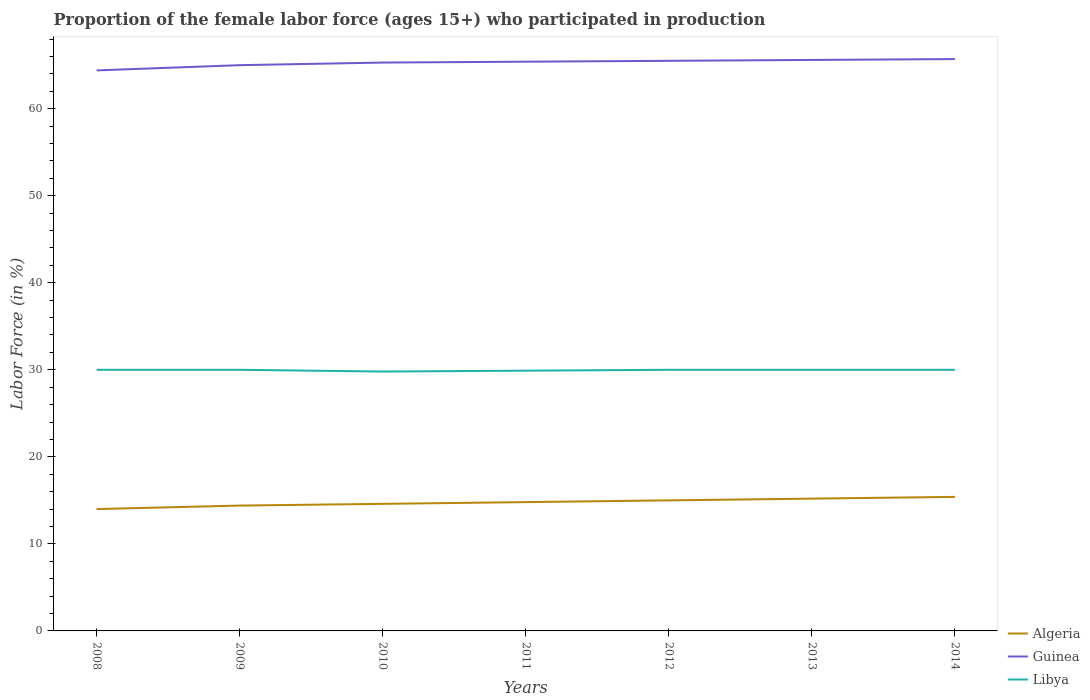Across all years, what is the maximum proportion of the female labor force who participated in production in Guinea?
Your answer should be very brief. 64.4. What is the total proportion of the female labor force who participated in production in Libya in the graph?
Your response must be concise. 0.1. What is the difference between the highest and the second highest proportion of the female labor force who participated in production in Guinea?
Keep it short and to the point. 1.3. What is the difference between the highest and the lowest proportion of the female labor force who participated in production in Algeria?
Provide a short and direct response. 4. How many years are there in the graph?
Your response must be concise. 7. What is the difference between two consecutive major ticks on the Y-axis?
Keep it short and to the point. 10. How many legend labels are there?
Provide a short and direct response. 3. What is the title of the graph?
Offer a terse response. Proportion of the female labor force (ages 15+) who participated in production. Does "Middle East & North Africa (developing only)" appear as one of the legend labels in the graph?
Offer a terse response. No. What is the label or title of the X-axis?
Offer a terse response. Years. What is the label or title of the Y-axis?
Your response must be concise. Labor Force (in %). What is the Labor Force (in %) in Guinea in 2008?
Your answer should be compact. 64.4. What is the Labor Force (in %) in Libya in 2008?
Keep it short and to the point. 30. What is the Labor Force (in %) of Algeria in 2009?
Offer a very short reply. 14.4. What is the Labor Force (in %) in Libya in 2009?
Ensure brevity in your answer.  30. What is the Labor Force (in %) in Algeria in 2010?
Provide a succinct answer. 14.6. What is the Labor Force (in %) of Guinea in 2010?
Provide a succinct answer. 65.3. What is the Labor Force (in %) of Libya in 2010?
Provide a succinct answer. 29.8. What is the Labor Force (in %) in Algeria in 2011?
Your response must be concise. 14.8. What is the Labor Force (in %) of Guinea in 2011?
Your response must be concise. 65.4. What is the Labor Force (in %) of Libya in 2011?
Keep it short and to the point. 29.9. What is the Labor Force (in %) in Algeria in 2012?
Your answer should be compact. 15. What is the Labor Force (in %) in Guinea in 2012?
Offer a very short reply. 65.5. What is the Labor Force (in %) in Libya in 2012?
Your answer should be compact. 30. What is the Labor Force (in %) of Algeria in 2013?
Your response must be concise. 15.2. What is the Labor Force (in %) in Guinea in 2013?
Ensure brevity in your answer.  65.6. What is the Labor Force (in %) in Algeria in 2014?
Keep it short and to the point. 15.4. What is the Labor Force (in %) in Guinea in 2014?
Your answer should be compact. 65.7. Across all years, what is the maximum Labor Force (in %) of Algeria?
Your answer should be compact. 15.4. Across all years, what is the maximum Labor Force (in %) of Guinea?
Offer a terse response. 65.7. Across all years, what is the maximum Labor Force (in %) of Libya?
Make the answer very short. 30. Across all years, what is the minimum Labor Force (in %) of Algeria?
Your response must be concise. 14. Across all years, what is the minimum Labor Force (in %) of Guinea?
Keep it short and to the point. 64.4. Across all years, what is the minimum Labor Force (in %) of Libya?
Provide a succinct answer. 29.8. What is the total Labor Force (in %) in Algeria in the graph?
Ensure brevity in your answer.  103.4. What is the total Labor Force (in %) of Guinea in the graph?
Offer a very short reply. 456.9. What is the total Labor Force (in %) of Libya in the graph?
Make the answer very short. 209.7. What is the difference between the Labor Force (in %) of Algeria in 2008 and that in 2009?
Your response must be concise. -0.4. What is the difference between the Labor Force (in %) of Guinea in 2008 and that in 2009?
Your response must be concise. -0.6. What is the difference between the Labor Force (in %) of Libya in 2008 and that in 2009?
Your answer should be very brief. 0. What is the difference between the Labor Force (in %) in Guinea in 2008 and that in 2010?
Offer a terse response. -0.9. What is the difference between the Labor Force (in %) in Libya in 2008 and that in 2010?
Your response must be concise. 0.2. What is the difference between the Labor Force (in %) of Algeria in 2008 and that in 2011?
Ensure brevity in your answer.  -0.8. What is the difference between the Labor Force (in %) in Guinea in 2008 and that in 2011?
Offer a terse response. -1. What is the difference between the Labor Force (in %) of Algeria in 2008 and that in 2012?
Keep it short and to the point. -1. What is the difference between the Labor Force (in %) of Guinea in 2008 and that in 2013?
Offer a terse response. -1.2. What is the difference between the Labor Force (in %) in Libya in 2008 and that in 2013?
Ensure brevity in your answer.  0. What is the difference between the Labor Force (in %) in Libya in 2008 and that in 2014?
Provide a succinct answer. 0. What is the difference between the Labor Force (in %) in Libya in 2009 and that in 2011?
Offer a terse response. 0.1. What is the difference between the Labor Force (in %) in Libya in 2009 and that in 2012?
Keep it short and to the point. 0. What is the difference between the Labor Force (in %) in Algeria in 2009 and that in 2014?
Your answer should be compact. -1. What is the difference between the Labor Force (in %) of Guinea in 2009 and that in 2014?
Make the answer very short. -0.7. What is the difference between the Labor Force (in %) in Algeria in 2010 and that in 2011?
Make the answer very short. -0.2. What is the difference between the Labor Force (in %) of Guinea in 2010 and that in 2011?
Ensure brevity in your answer.  -0.1. What is the difference between the Labor Force (in %) in Libya in 2010 and that in 2011?
Make the answer very short. -0.1. What is the difference between the Labor Force (in %) in Algeria in 2010 and that in 2012?
Ensure brevity in your answer.  -0.4. What is the difference between the Labor Force (in %) of Algeria in 2010 and that in 2013?
Make the answer very short. -0.6. What is the difference between the Labor Force (in %) of Guinea in 2010 and that in 2013?
Your response must be concise. -0.3. What is the difference between the Labor Force (in %) in Libya in 2010 and that in 2013?
Keep it short and to the point. -0.2. What is the difference between the Labor Force (in %) of Guinea in 2010 and that in 2014?
Ensure brevity in your answer.  -0.4. What is the difference between the Labor Force (in %) of Libya in 2010 and that in 2014?
Provide a succinct answer. -0.2. What is the difference between the Labor Force (in %) of Algeria in 2011 and that in 2014?
Offer a very short reply. -0.6. What is the difference between the Labor Force (in %) in Guinea in 2011 and that in 2014?
Provide a short and direct response. -0.3. What is the difference between the Labor Force (in %) of Libya in 2011 and that in 2014?
Your answer should be compact. -0.1. What is the difference between the Labor Force (in %) in Guinea in 2012 and that in 2013?
Provide a succinct answer. -0.1. What is the difference between the Labor Force (in %) in Libya in 2012 and that in 2013?
Offer a very short reply. 0. What is the difference between the Labor Force (in %) of Guinea in 2012 and that in 2014?
Your response must be concise. -0.2. What is the difference between the Labor Force (in %) in Libya in 2012 and that in 2014?
Keep it short and to the point. 0. What is the difference between the Labor Force (in %) of Algeria in 2008 and the Labor Force (in %) of Guinea in 2009?
Keep it short and to the point. -51. What is the difference between the Labor Force (in %) of Guinea in 2008 and the Labor Force (in %) of Libya in 2009?
Offer a very short reply. 34.4. What is the difference between the Labor Force (in %) in Algeria in 2008 and the Labor Force (in %) in Guinea in 2010?
Give a very brief answer. -51.3. What is the difference between the Labor Force (in %) in Algeria in 2008 and the Labor Force (in %) in Libya in 2010?
Offer a terse response. -15.8. What is the difference between the Labor Force (in %) in Guinea in 2008 and the Labor Force (in %) in Libya in 2010?
Your response must be concise. 34.6. What is the difference between the Labor Force (in %) in Algeria in 2008 and the Labor Force (in %) in Guinea in 2011?
Your answer should be very brief. -51.4. What is the difference between the Labor Force (in %) of Algeria in 2008 and the Labor Force (in %) of Libya in 2011?
Your answer should be very brief. -15.9. What is the difference between the Labor Force (in %) in Guinea in 2008 and the Labor Force (in %) in Libya in 2011?
Provide a short and direct response. 34.5. What is the difference between the Labor Force (in %) in Algeria in 2008 and the Labor Force (in %) in Guinea in 2012?
Your answer should be compact. -51.5. What is the difference between the Labor Force (in %) in Guinea in 2008 and the Labor Force (in %) in Libya in 2012?
Your answer should be compact. 34.4. What is the difference between the Labor Force (in %) of Algeria in 2008 and the Labor Force (in %) of Guinea in 2013?
Give a very brief answer. -51.6. What is the difference between the Labor Force (in %) in Algeria in 2008 and the Labor Force (in %) in Libya in 2013?
Keep it short and to the point. -16. What is the difference between the Labor Force (in %) in Guinea in 2008 and the Labor Force (in %) in Libya in 2013?
Keep it short and to the point. 34.4. What is the difference between the Labor Force (in %) in Algeria in 2008 and the Labor Force (in %) in Guinea in 2014?
Offer a very short reply. -51.7. What is the difference between the Labor Force (in %) in Algeria in 2008 and the Labor Force (in %) in Libya in 2014?
Offer a very short reply. -16. What is the difference between the Labor Force (in %) of Guinea in 2008 and the Labor Force (in %) of Libya in 2014?
Your response must be concise. 34.4. What is the difference between the Labor Force (in %) of Algeria in 2009 and the Labor Force (in %) of Guinea in 2010?
Give a very brief answer. -50.9. What is the difference between the Labor Force (in %) of Algeria in 2009 and the Labor Force (in %) of Libya in 2010?
Your answer should be very brief. -15.4. What is the difference between the Labor Force (in %) of Guinea in 2009 and the Labor Force (in %) of Libya in 2010?
Your answer should be compact. 35.2. What is the difference between the Labor Force (in %) of Algeria in 2009 and the Labor Force (in %) of Guinea in 2011?
Offer a very short reply. -51. What is the difference between the Labor Force (in %) in Algeria in 2009 and the Labor Force (in %) in Libya in 2011?
Offer a very short reply. -15.5. What is the difference between the Labor Force (in %) in Guinea in 2009 and the Labor Force (in %) in Libya in 2011?
Your answer should be compact. 35.1. What is the difference between the Labor Force (in %) in Algeria in 2009 and the Labor Force (in %) in Guinea in 2012?
Make the answer very short. -51.1. What is the difference between the Labor Force (in %) in Algeria in 2009 and the Labor Force (in %) in Libya in 2012?
Give a very brief answer. -15.6. What is the difference between the Labor Force (in %) in Algeria in 2009 and the Labor Force (in %) in Guinea in 2013?
Provide a short and direct response. -51.2. What is the difference between the Labor Force (in %) in Algeria in 2009 and the Labor Force (in %) in Libya in 2013?
Provide a succinct answer. -15.6. What is the difference between the Labor Force (in %) in Guinea in 2009 and the Labor Force (in %) in Libya in 2013?
Ensure brevity in your answer.  35. What is the difference between the Labor Force (in %) of Algeria in 2009 and the Labor Force (in %) of Guinea in 2014?
Make the answer very short. -51.3. What is the difference between the Labor Force (in %) of Algeria in 2009 and the Labor Force (in %) of Libya in 2014?
Your response must be concise. -15.6. What is the difference between the Labor Force (in %) of Guinea in 2009 and the Labor Force (in %) of Libya in 2014?
Offer a terse response. 35. What is the difference between the Labor Force (in %) of Algeria in 2010 and the Labor Force (in %) of Guinea in 2011?
Provide a succinct answer. -50.8. What is the difference between the Labor Force (in %) in Algeria in 2010 and the Labor Force (in %) in Libya in 2011?
Your response must be concise. -15.3. What is the difference between the Labor Force (in %) of Guinea in 2010 and the Labor Force (in %) of Libya in 2011?
Your response must be concise. 35.4. What is the difference between the Labor Force (in %) in Algeria in 2010 and the Labor Force (in %) in Guinea in 2012?
Ensure brevity in your answer.  -50.9. What is the difference between the Labor Force (in %) of Algeria in 2010 and the Labor Force (in %) of Libya in 2012?
Offer a very short reply. -15.4. What is the difference between the Labor Force (in %) in Guinea in 2010 and the Labor Force (in %) in Libya in 2012?
Give a very brief answer. 35.3. What is the difference between the Labor Force (in %) in Algeria in 2010 and the Labor Force (in %) in Guinea in 2013?
Provide a short and direct response. -51. What is the difference between the Labor Force (in %) of Algeria in 2010 and the Labor Force (in %) of Libya in 2013?
Provide a succinct answer. -15.4. What is the difference between the Labor Force (in %) in Guinea in 2010 and the Labor Force (in %) in Libya in 2013?
Provide a short and direct response. 35.3. What is the difference between the Labor Force (in %) of Algeria in 2010 and the Labor Force (in %) of Guinea in 2014?
Offer a terse response. -51.1. What is the difference between the Labor Force (in %) of Algeria in 2010 and the Labor Force (in %) of Libya in 2014?
Your answer should be compact. -15.4. What is the difference between the Labor Force (in %) in Guinea in 2010 and the Labor Force (in %) in Libya in 2014?
Give a very brief answer. 35.3. What is the difference between the Labor Force (in %) of Algeria in 2011 and the Labor Force (in %) of Guinea in 2012?
Provide a succinct answer. -50.7. What is the difference between the Labor Force (in %) in Algeria in 2011 and the Labor Force (in %) in Libya in 2012?
Offer a terse response. -15.2. What is the difference between the Labor Force (in %) in Guinea in 2011 and the Labor Force (in %) in Libya in 2012?
Your answer should be very brief. 35.4. What is the difference between the Labor Force (in %) in Algeria in 2011 and the Labor Force (in %) in Guinea in 2013?
Offer a terse response. -50.8. What is the difference between the Labor Force (in %) of Algeria in 2011 and the Labor Force (in %) of Libya in 2013?
Your answer should be very brief. -15.2. What is the difference between the Labor Force (in %) in Guinea in 2011 and the Labor Force (in %) in Libya in 2013?
Your response must be concise. 35.4. What is the difference between the Labor Force (in %) in Algeria in 2011 and the Labor Force (in %) in Guinea in 2014?
Provide a succinct answer. -50.9. What is the difference between the Labor Force (in %) of Algeria in 2011 and the Labor Force (in %) of Libya in 2014?
Offer a terse response. -15.2. What is the difference between the Labor Force (in %) of Guinea in 2011 and the Labor Force (in %) of Libya in 2014?
Make the answer very short. 35.4. What is the difference between the Labor Force (in %) in Algeria in 2012 and the Labor Force (in %) in Guinea in 2013?
Give a very brief answer. -50.6. What is the difference between the Labor Force (in %) in Algeria in 2012 and the Labor Force (in %) in Libya in 2013?
Provide a short and direct response. -15. What is the difference between the Labor Force (in %) in Guinea in 2012 and the Labor Force (in %) in Libya in 2013?
Provide a short and direct response. 35.5. What is the difference between the Labor Force (in %) in Algeria in 2012 and the Labor Force (in %) in Guinea in 2014?
Provide a succinct answer. -50.7. What is the difference between the Labor Force (in %) in Guinea in 2012 and the Labor Force (in %) in Libya in 2014?
Provide a short and direct response. 35.5. What is the difference between the Labor Force (in %) in Algeria in 2013 and the Labor Force (in %) in Guinea in 2014?
Ensure brevity in your answer.  -50.5. What is the difference between the Labor Force (in %) of Algeria in 2013 and the Labor Force (in %) of Libya in 2014?
Your answer should be compact. -14.8. What is the difference between the Labor Force (in %) of Guinea in 2013 and the Labor Force (in %) of Libya in 2014?
Your answer should be very brief. 35.6. What is the average Labor Force (in %) in Algeria per year?
Give a very brief answer. 14.77. What is the average Labor Force (in %) of Guinea per year?
Offer a very short reply. 65.27. What is the average Labor Force (in %) of Libya per year?
Ensure brevity in your answer.  29.96. In the year 2008, what is the difference between the Labor Force (in %) in Algeria and Labor Force (in %) in Guinea?
Provide a short and direct response. -50.4. In the year 2008, what is the difference between the Labor Force (in %) of Algeria and Labor Force (in %) of Libya?
Ensure brevity in your answer.  -16. In the year 2008, what is the difference between the Labor Force (in %) of Guinea and Labor Force (in %) of Libya?
Your answer should be compact. 34.4. In the year 2009, what is the difference between the Labor Force (in %) in Algeria and Labor Force (in %) in Guinea?
Your answer should be compact. -50.6. In the year 2009, what is the difference between the Labor Force (in %) in Algeria and Labor Force (in %) in Libya?
Offer a terse response. -15.6. In the year 2010, what is the difference between the Labor Force (in %) of Algeria and Labor Force (in %) of Guinea?
Your answer should be very brief. -50.7. In the year 2010, what is the difference between the Labor Force (in %) of Algeria and Labor Force (in %) of Libya?
Make the answer very short. -15.2. In the year 2010, what is the difference between the Labor Force (in %) in Guinea and Labor Force (in %) in Libya?
Your response must be concise. 35.5. In the year 2011, what is the difference between the Labor Force (in %) in Algeria and Labor Force (in %) in Guinea?
Your response must be concise. -50.6. In the year 2011, what is the difference between the Labor Force (in %) in Algeria and Labor Force (in %) in Libya?
Ensure brevity in your answer.  -15.1. In the year 2011, what is the difference between the Labor Force (in %) in Guinea and Labor Force (in %) in Libya?
Your answer should be very brief. 35.5. In the year 2012, what is the difference between the Labor Force (in %) of Algeria and Labor Force (in %) of Guinea?
Offer a very short reply. -50.5. In the year 2012, what is the difference between the Labor Force (in %) in Algeria and Labor Force (in %) in Libya?
Your response must be concise. -15. In the year 2012, what is the difference between the Labor Force (in %) of Guinea and Labor Force (in %) of Libya?
Offer a terse response. 35.5. In the year 2013, what is the difference between the Labor Force (in %) in Algeria and Labor Force (in %) in Guinea?
Provide a short and direct response. -50.4. In the year 2013, what is the difference between the Labor Force (in %) of Algeria and Labor Force (in %) of Libya?
Ensure brevity in your answer.  -14.8. In the year 2013, what is the difference between the Labor Force (in %) in Guinea and Labor Force (in %) in Libya?
Keep it short and to the point. 35.6. In the year 2014, what is the difference between the Labor Force (in %) in Algeria and Labor Force (in %) in Guinea?
Offer a very short reply. -50.3. In the year 2014, what is the difference between the Labor Force (in %) of Algeria and Labor Force (in %) of Libya?
Your answer should be compact. -14.6. In the year 2014, what is the difference between the Labor Force (in %) in Guinea and Labor Force (in %) in Libya?
Provide a short and direct response. 35.7. What is the ratio of the Labor Force (in %) in Algeria in 2008 to that in 2009?
Make the answer very short. 0.97. What is the ratio of the Labor Force (in %) of Algeria in 2008 to that in 2010?
Offer a very short reply. 0.96. What is the ratio of the Labor Force (in %) of Guinea in 2008 to that in 2010?
Ensure brevity in your answer.  0.99. What is the ratio of the Labor Force (in %) of Algeria in 2008 to that in 2011?
Provide a succinct answer. 0.95. What is the ratio of the Labor Force (in %) in Guinea in 2008 to that in 2011?
Provide a succinct answer. 0.98. What is the ratio of the Labor Force (in %) of Guinea in 2008 to that in 2012?
Provide a succinct answer. 0.98. What is the ratio of the Labor Force (in %) in Libya in 2008 to that in 2012?
Give a very brief answer. 1. What is the ratio of the Labor Force (in %) of Algeria in 2008 to that in 2013?
Provide a short and direct response. 0.92. What is the ratio of the Labor Force (in %) in Guinea in 2008 to that in 2013?
Offer a terse response. 0.98. What is the ratio of the Labor Force (in %) in Libya in 2008 to that in 2013?
Your answer should be very brief. 1. What is the ratio of the Labor Force (in %) in Guinea in 2008 to that in 2014?
Give a very brief answer. 0.98. What is the ratio of the Labor Force (in %) of Algeria in 2009 to that in 2010?
Your answer should be very brief. 0.99. What is the ratio of the Labor Force (in %) in Libya in 2009 to that in 2010?
Offer a terse response. 1.01. What is the ratio of the Labor Force (in %) in Algeria in 2009 to that in 2011?
Ensure brevity in your answer.  0.97. What is the ratio of the Labor Force (in %) in Libya in 2009 to that in 2011?
Keep it short and to the point. 1. What is the ratio of the Labor Force (in %) in Algeria in 2009 to that in 2012?
Provide a short and direct response. 0.96. What is the ratio of the Labor Force (in %) of Guinea in 2009 to that in 2012?
Your answer should be very brief. 0.99. What is the ratio of the Labor Force (in %) in Libya in 2009 to that in 2012?
Ensure brevity in your answer.  1. What is the ratio of the Labor Force (in %) of Algeria in 2009 to that in 2013?
Give a very brief answer. 0.95. What is the ratio of the Labor Force (in %) in Guinea in 2009 to that in 2013?
Your answer should be very brief. 0.99. What is the ratio of the Labor Force (in %) of Libya in 2009 to that in 2013?
Provide a short and direct response. 1. What is the ratio of the Labor Force (in %) of Algeria in 2009 to that in 2014?
Ensure brevity in your answer.  0.94. What is the ratio of the Labor Force (in %) of Guinea in 2009 to that in 2014?
Keep it short and to the point. 0.99. What is the ratio of the Labor Force (in %) in Algeria in 2010 to that in 2011?
Keep it short and to the point. 0.99. What is the ratio of the Labor Force (in %) in Libya in 2010 to that in 2011?
Give a very brief answer. 1. What is the ratio of the Labor Force (in %) in Algeria in 2010 to that in 2012?
Offer a very short reply. 0.97. What is the ratio of the Labor Force (in %) of Guinea in 2010 to that in 2012?
Ensure brevity in your answer.  1. What is the ratio of the Labor Force (in %) of Libya in 2010 to that in 2012?
Keep it short and to the point. 0.99. What is the ratio of the Labor Force (in %) in Algeria in 2010 to that in 2013?
Your answer should be very brief. 0.96. What is the ratio of the Labor Force (in %) of Libya in 2010 to that in 2013?
Provide a short and direct response. 0.99. What is the ratio of the Labor Force (in %) in Algeria in 2010 to that in 2014?
Keep it short and to the point. 0.95. What is the ratio of the Labor Force (in %) in Libya in 2010 to that in 2014?
Your answer should be compact. 0.99. What is the ratio of the Labor Force (in %) of Algeria in 2011 to that in 2012?
Your response must be concise. 0.99. What is the ratio of the Labor Force (in %) of Guinea in 2011 to that in 2012?
Offer a very short reply. 1. What is the ratio of the Labor Force (in %) of Algeria in 2011 to that in 2013?
Keep it short and to the point. 0.97. What is the ratio of the Labor Force (in %) of Algeria in 2011 to that in 2014?
Your answer should be very brief. 0.96. What is the ratio of the Labor Force (in %) in Guinea in 2012 to that in 2013?
Ensure brevity in your answer.  1. What is the ratio of the Labor Force (in %) of Guinea in 2012 to that in 2014?
Your answer should be very brief. 1. What is the ratio of the Labor Force (in %) in Libya in 2012 to that in 2014?
Your answer should be compact. 1. What is the difference between the highest and the second highest Labor Force (in %) of Guinea?
Keep it short and to the point. 0.1. What is the difference between the highest and the second highest Labor Force (in %) in Libya?
Keep it short and to the point. 0. What is the difference between the highest and the lowest Labor Force (in %) of Algeria?
Offer a very short reply. 1.4. What is the difference between the highest and the lowest Labor Force (in %) in Guinea?
Your answer should be compact. 1.3. 